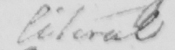Can you read and transcribe this handwriting? literal 